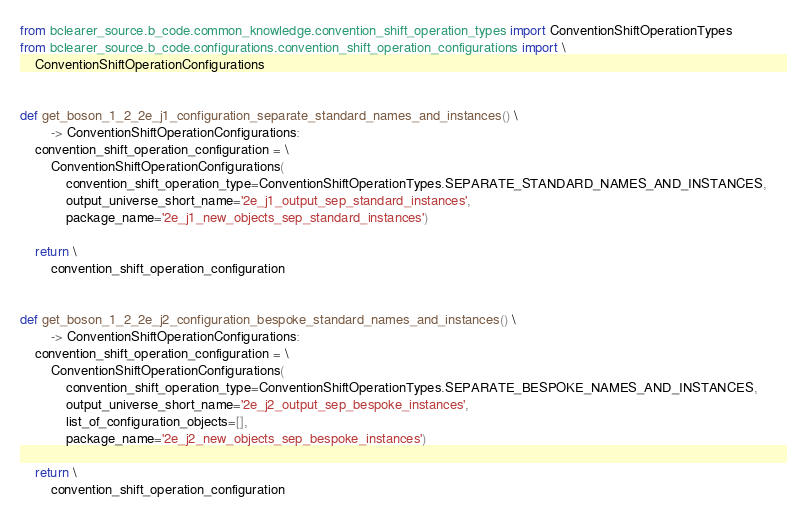<code> <loc_0><loc_0><loc_500><loc_500><_Python_>from bclearer_source.b_code.common_knowledge.convention_shift_operation_types import ConventionShiftOperationTypes
from bclearer_source.b_code.configurations.convention_shift_operation_configurations import \
    ConventionShiftOperationConfigurations


def get_boson_1_2_2e_j1_configuration_separate_standard_names_and_instances() \
        -> ConventionShiftOperationConfigurations:
    convention_shift_operation_configuration = \
        ConventionShiftOperationConfigurations(
            convention_shift_operation_type=ConventionShiftOperationTypes.SEPARATE_STANDARD_NAMES_AND_INSTANCES,
            output_universe_short_name='2e_j1_output_sep_standard_instances',
            package_name='2e_j1_new_objects_sep_standard_instances')

    return \
        convention_shift_operation_configuration


def get_boson_1_2_2e_j2_configuration_bespoke_standard_names_and_instances() \
        -> ConventionShiftOperationConfigurations:
    convention_shift_operation_configuration = \
        ConventionShiftOperationConfigurations(
            convention_shift_operation_type=ConventionShiftOperationTypes.SEPARATE_BESPOKE_NAMES_AND_INSTANCES,
            output_universe_short_name='2e_j2_output_sep_bespoke_instances',
            list_of_configuration_objects=[],
            package_name='2e_j2_new_objects_sep_bespoke_instances')

    return \
        convention_shift_operation_configuration
</code> 